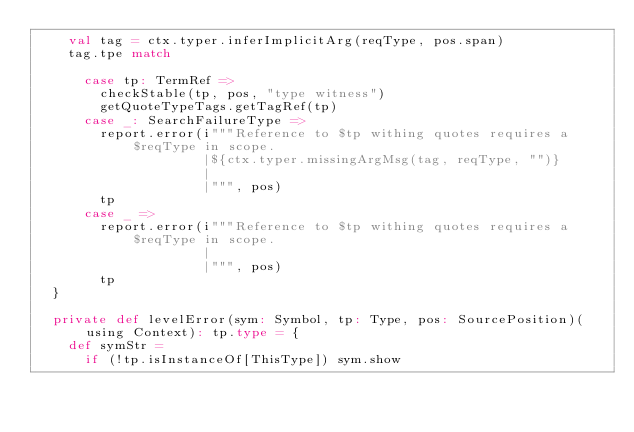<code> <loc_0><loc_0><loc_500><loc_500><_Scala_>    val tag = ctx.typer.inferImplicitArg(reqType, pos.span)
    tag.tpe match

      case tp: TermRef =>
        checkStable(tp, pos, "type witness")
        getQuoteTypeTags.getTagRef(tp)
      case _: SearchFailureType =>
        report.error(i"""Reference to $tp withing quotes requires a $reqType in scope.
                     |${ctx.typer.missingArgMsg(tag, reqType, "")}
                     |
                     |""", pos)
        tp
      case _ =>
        report.error(i"""Reference to $tp withing quotes requires a $reqType in scope.
                     |
                     |""", pos)
        tp
  }

  private def levelError(sym: Symbol, tp: Type, pos: SourcePosition)(using Context): tp.type = {
    def symStr =
      if (!tp.isInstanceOf[ThisType]) sym.show</code> 